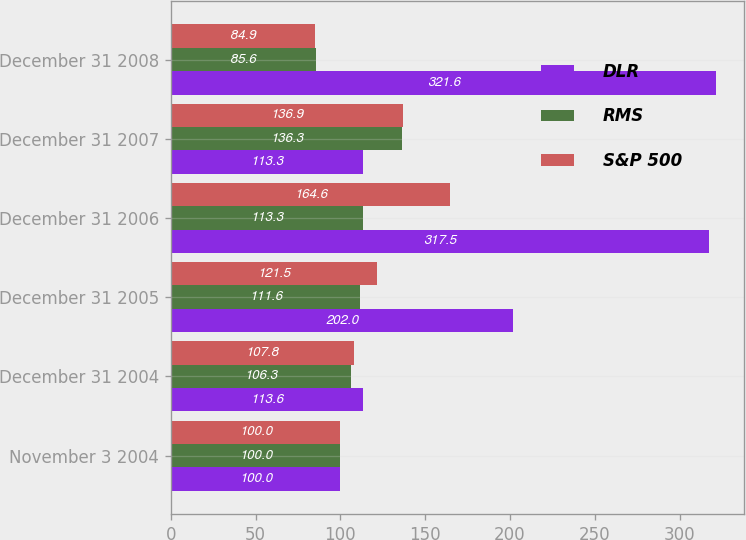Convert chart. <chart><loc_0><loc_0><loc_500><loc_500><stacked_bar_chart><ecel><fcel>November 3 2004<fcel>December 31 2004<fcel>December 31 2005<fcel>December 31 2006<fcel>December 31 2007<fcel>December 31 2008<nl><fcel>DLR<fcel>100<fcel>113.6<fcel>202<fcel>317.5<fcel>113.3<fcel>321.6<nl><fcel>RMS<fcel>100<fcel>106.3<fcel>111.6<fcel>113.3<fcel>136.3<fcel>85.6<nl><fcel>S&P 500<fcel>100<fcel>107.8<fcel>121.5<fcel>164.6<fcel>136.9<fcel>84.9<nl></chart> 